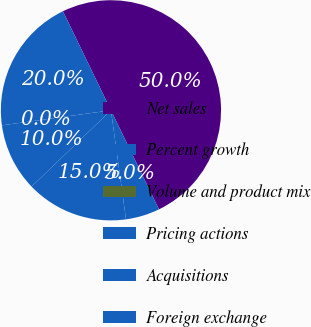Convert chart. <chart><loc_0><loc_0><loc_500><loc_500><pie_chart><fcel>Net sales<fcel>Percent growth<fcel>Volume and product mix<fcel>Pricing actions<fcel>Acquisitions<fcel>Foreign exchange<nl><fcel>50.0%<fcel>20.0%<fcel>0.0%<fcel>10.0%<fcel>15.0%<fcel>5.0%<nl></chart> 